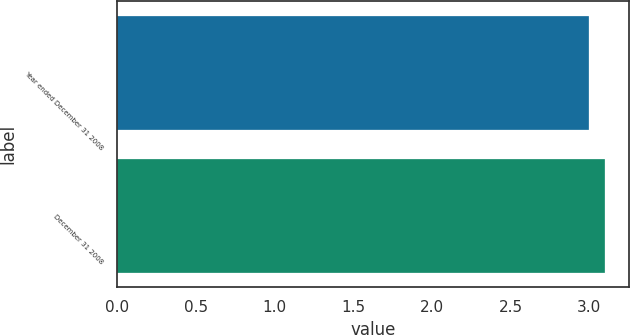<chart> <loc_0><loc_0><loc_500><loc_500><bar_chart><fcel>Year ended December 31 2008<fcel>December 31 2008<nl><fcel>3<fcel>3.1<nl></chart> 